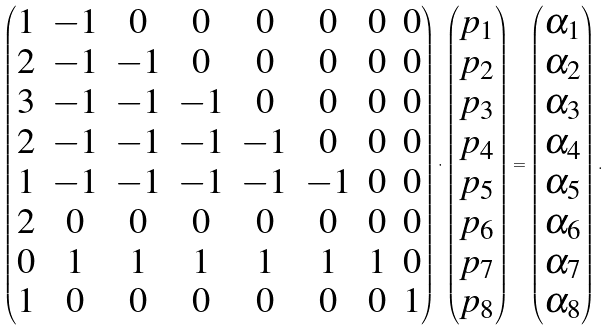<formula> <loc_0><loc_0><loc_500><loc_500>\begin{pmatrix} 1 & - 1 & 0 & 0 & 0 & 0 & 0 & 0 \\ 2 & - 1 & - 1 & 0 & 0 & 0 & 0 & 0 \\ 3 & - 1 & - 1 & - 1 & 0 & 0 & 0 & 0 \\ 2 & - 1 & - 1 & - 1 & - 1 & 0 & 0 & 0 \\ 1 & - 1 & - 1 & - 1 & - 1 & - 1 & 0 & 0 \\ 2 & 0 & 0 & 0 & 0 & 0 & 0 & 0 \\ 0 & 1 & 1 & 1 & 1 & 1 & 1 & 0 \\ 1 & 0 & 0 & 0 & 0 & 0 & 0 & 1 \\ \end{pmatrix} \cdot \begin{pmatrix} p _ { 1 } \\ p _ { 2 } \\ p _ { 3 } \\ p _ { 4 } \\ p _ { 5 } \\ p _ { 6 } \\ p _ { 7 } \\ p _ { 8 } \\ \end{pmatrix} = \begin{pmatrix} \alpha _ { 1 } \\ \alpha _ { 2 } \\ \alpha _ { 3 } \\ \alpha _ { 4 } \\ \alpha _ { 5 } \\ \alpha _ { 6 } \\ \alpha _ { 7 } \\ \alpha _ { 8 } \\ \end{pmatrix} .</formula> 